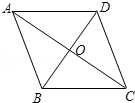First perform reasoning, then finally select the question from the choices in the following format: Answer: xxx.
Question: In the diamond ABCD, given that AC is 32 units long and BD is 24 units long, what is the side length of the diamond?
Choices:
A: 16.0
B: 20.0
C: 24.0
D: 40.0 Since the diagonals of a rhombus are perpendicular and bisect each other, we have BO=OD=3 and AO=OC=4. Therefore, using the Pythagorean theorem, we can find that AB=√{4²+3²}=5. Thus, the length of the rhombus is 20 units. Therefore, the answer is B.
Answer:B 